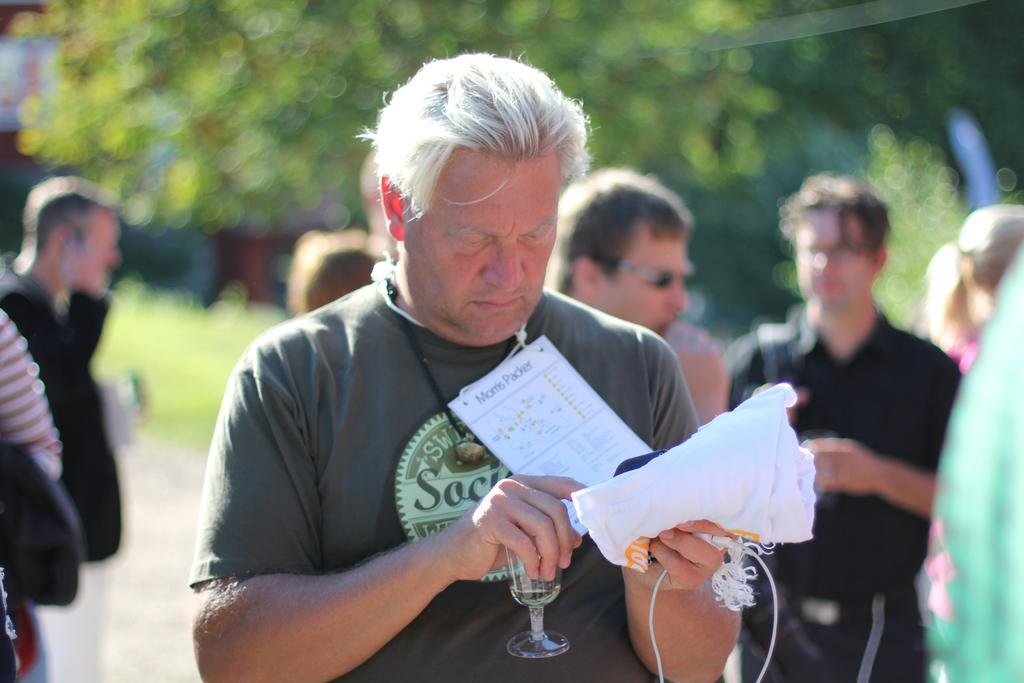Can you describe this image briefly? In this image I can see the person holding few papers. In the background I can see few other people and few trees in green color. 